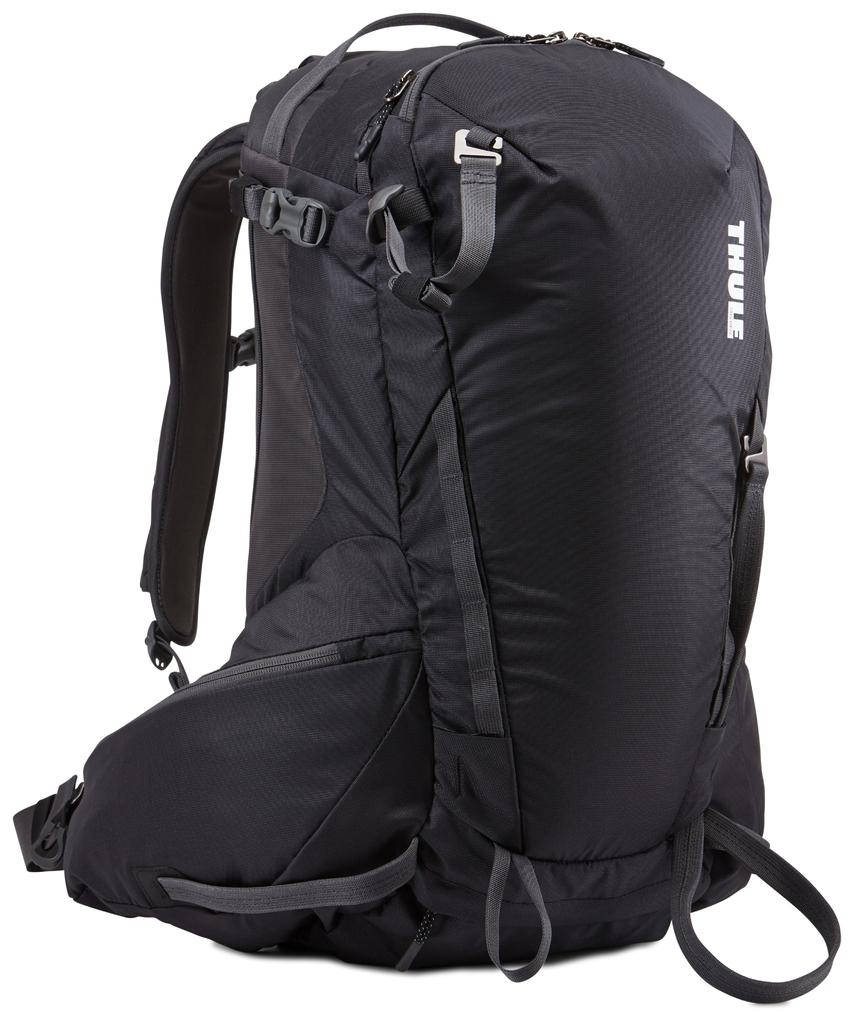Provide a one-sentence caption for the provided image. A product shot of a black Thule backpack. 